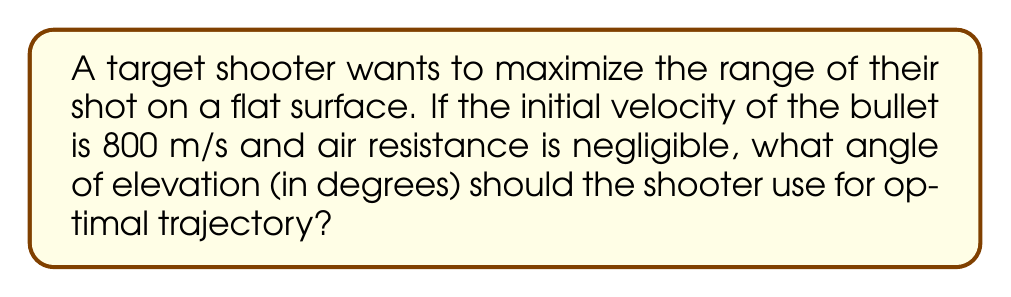What is the answer to this math problem? To solve this problem, we need to use the principles of projectile motion and determine the angle that maximizes the horizontal range.

Step 1: Recall the range equation for projectile motion without air resistance:
$$R = \frac{v_0^2 \sin(2\theta)}{g}$$
Where:
$R$ is the range
$v_0$ is the initial velocity
$\theta$ is the angle of elevation
$g$ is the acceleration due to gravity (9.8 m/s²)

Step 2: To maximize the range, we need to maximize $\sin(2\theta)$. The sine function reaches its maximum value of 1 when its argument is 90°.

Step 3: Set up the equation:
$$2\theta = 90°$$

Step 4: Solve for $\theta$:
$$\theta = 45°$$

Step 5: Verify that this indeed gives the maximum range:
At $\theta = 45°$, $\sin(2\theta) = \sin(90°) = 1$, which is the maximum value the sine function can take.

Therefore, the optimal angle of elevation for maximum range is 45°.
Answer: 45° 